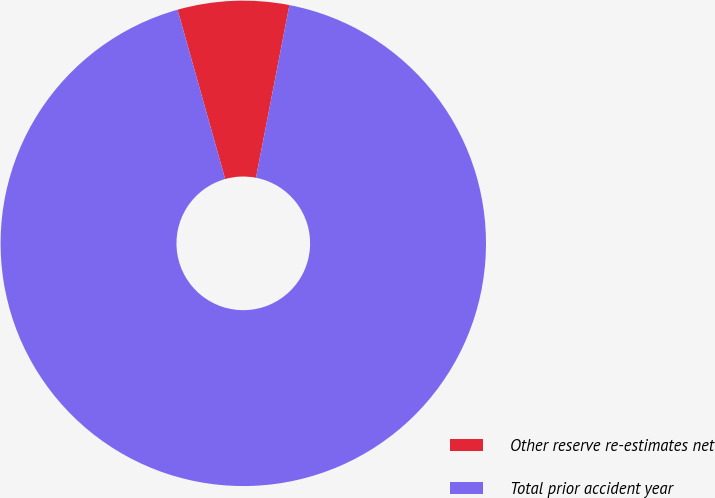<chart> <loc_0><loc_0><loc_500><loc_500><pie_chart><fcel>Other reserve re-estimates net<fcel>Total prior accident year<nl><fcel>7.41%<fcel>92.59%<nl></chart> 